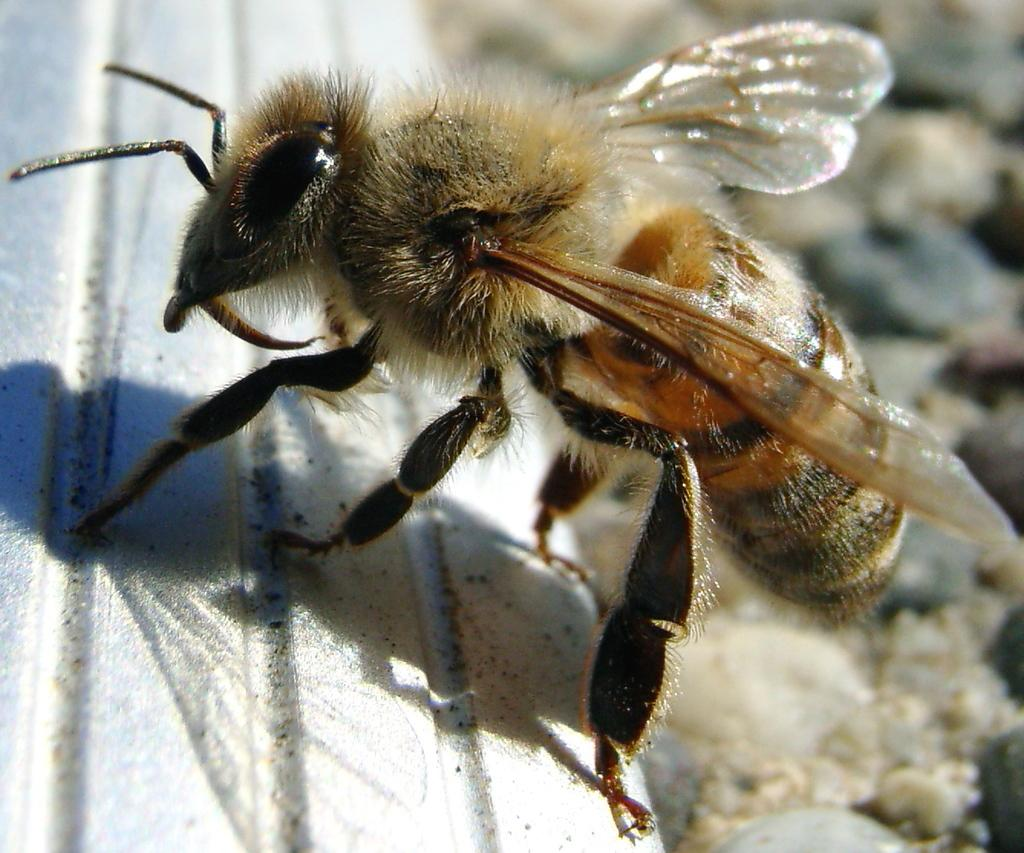What is the main subject on the left side of the image? There is a white object on the left side of the image. What is the white object hosting in the image? A honey bee is present on the white object. Can you describe the background of the image? The background of the image is blurred. What is the taste of the fire in the image? There is no fire present in the image, so it is not possible to determine its taste. 